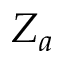<formula> <loc_0><loc_0><loc_500><loc_500>Z _ { a }</formula> 